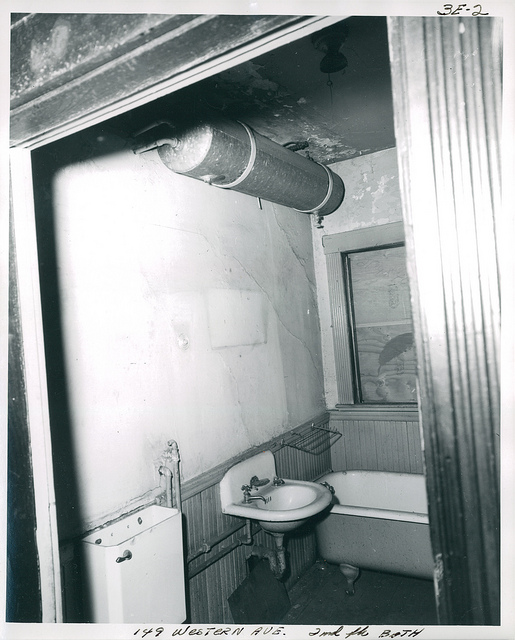Can you describe the overall condition of the bathroom? The bathroom appears to be in a state of disrepair, with noticeable wear and some damage. The wall paint is peeling, the ceiling has water damage, and the overall aesthetic suggests it has been some time since it was last updated or renovated. 